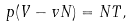<formula> <loc_0><loc_0><loc_500><loc_500>p ( V - v N ) = N T ,</formula> 